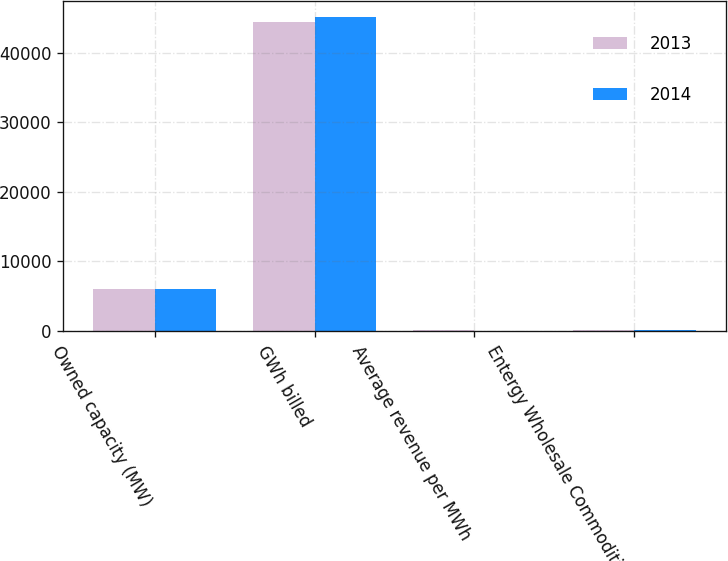<chart> <loc_0><loc_0><loc_500><loc_500><stacked_bar_chart><ecel><fcel>Owned capacity (MW)<fcel>GWh billed<fcel>Average revenue per MWh<fcel>Entergy Wholesale Commodities<nl><fcel>2013<fcel>6068<fcel>44424<fcel>60.84<fcel>91<nl><fcel>2014<fcel>6068<fcel>45127<fcel>50.86<fcel>89<nl></chart> 